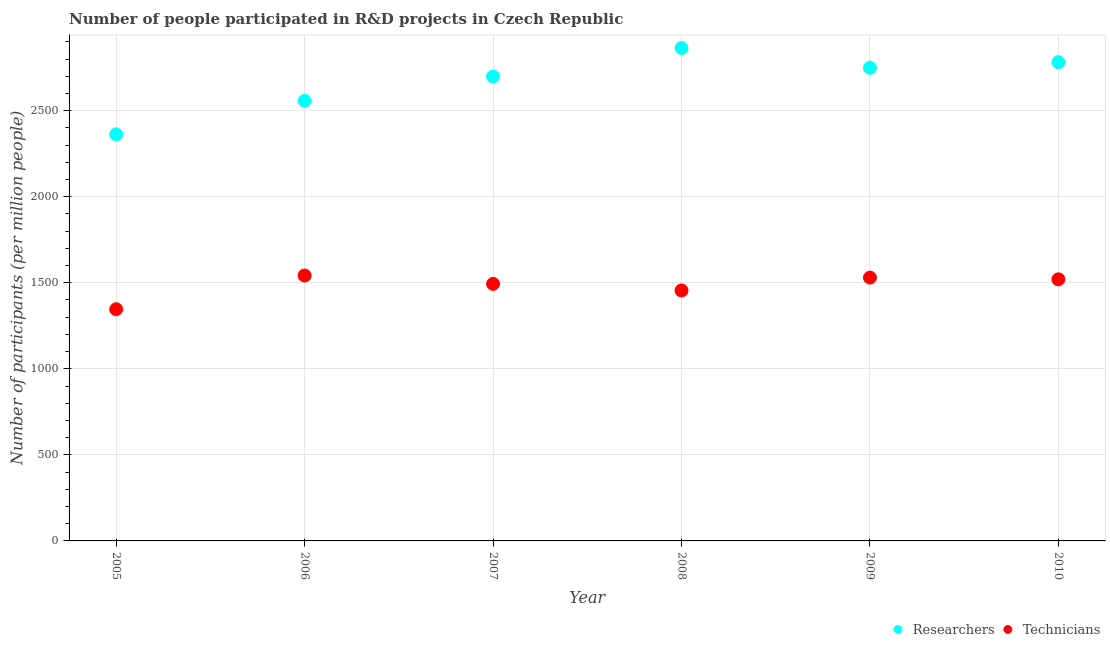Is the number of dotlines equal to the number of legend labels?
Offer a terse response. Yes. What is the number of researchers in 2010?
Keep it short and to the point. 2781.85. Across all years, what is the maximum number of technicians?
Your answer should be very brief. 1542.15. Across all years, what is the minimum number of researchers?
Make the answer very short. 2362.37. In which year was the number of technicians maximum?
Make the answer very short. 2006. What is the total number of researchers in the graph?
Give a very brief answer. 1.60e+04. What is the difference between the number of researchers in 2005 and that in 2008?
Your response must be concise. -502.15. What is the difference between the number of technicians in 2007 and the number of researchers in 2008?
Offer a very short reply. -1370.84. What is the average number of researchers per year?
Offer a very short reply. 2669.02. In the year 2010, what is the difference between the number of researchers and number of technicians?
Give a very brief answer. 1261.8. In how many years, is the number of technicians greater than 1200?
Provide a succinct answer. 6. What is the ratio of the number of researchers in 2005 to that in 2009?
Your response must be concise. 0.86. Is the number of researchers in 2006 less than that in 2009?
Provide a short and direct response. Yes. Is the difference between the number of technicians in 2008 and 2009 greater than the difference between the number of researchers in 2008 and 2009?
Ensure brevity in your answer.  No. What is the difference between the highest and the second highest number of technicians?
Ensure brevity in your answer.  12.06. What is the difference between the highest and the lowest number of technicians?
Your response must be concise. 195.97. Does the number of researchers monotonically increase over the years?
Your answer should be very brief. No. Is the number of researchers strictly greater than the number of technicians over the years?
Ensure brevity in your answer.  Yes. Is the number of technicians strictly less than the number of researchers over the years?
Give a very brief answer. Yes. How many dotlines are there?
Make the answer very short. 2. Does the graph contain any zero values?
Provide a succinct answer. No. Does the graph contain grids?
Keep it short and to the point. Yes. How many legend labels are there?
Your answer should be compact. 2. What is the title of the graph?
Provide a succinct answer. Number of people participated in R&D projects in Czech Republic. What is the label or title of the Y-axis?
Make the answer very short. Number of participants (per million people). What is the Number of participants (per million people) in Researchers in 2005?
Provide a short and direct response. 2362.37. What is the Number of participants (per million people) of Technicians in 2005?
Provide a short and direct response. 1346.19. What is the Number of participants (per million people) of Researchers in 2006?
Keep it short and to the point. 2557.31. What is the Number of participants (per million people) in Technicians in 2006?
Offer a terse response. 1542.15. What is the Number of participants (per million people) of Researchers in 2007?
Your answer should be compact. 2698.6. What is the Number of participants (per million people) of Technicians in 2007?
Provide a succinct answer. 1493.68. What is the Number of participants (per million people) of Researchers in 2008?
Offer a terse response. 2864.52. What is the Number of participants (per million people) in Technicians in 2008?
Keep it short and to the point. 1455.38. What is the Number of participants (per million people) of Researchers in 2009?
Your response must be concise. 2749.45. What is the Number of participants (per million people) of Technicians in 2009?
Your response must be concise. 1530.09. What is the Number of participants (per million people) of Researchers in 2010?
Provide a short and direct response. 2781.85. What is the Number of participants (per million people) in Technicians in 2010?
Ensure brevity in your answer.  1520.06. Across all years, what is the maximum Number of participants (per million people) in Researchers?
Make the answer very short. 2864.52. Across all years, what is the maximum Number of participants (per million people) of Technicians?
Your answer should be very brief. 1542.15. Across all years, what is the minimum Number of participants (per million people) of Researchers?
Provide a succinct answer. 2362.37. Across all years, what is the minimum Number of participants (per million people) of Technicians?
Provide a short and direct response. 1346.19. What is the total Number of participants (per million people) of Researchers in the graph?
Offer a terse response. 1.60e+04. What is the total Number of participants (per million people) in Technicians in the graph?
Offer a terse response. 8887.55. What is the difference between the Number of participants (per million people) of Researchers in 2005 and that in 2006?
Make the answer very short. -194.94. What is the difference between the Number of participants (per million people) in Technicians in 2005 and that in 2006?
Provide a short and direct response. -195.97. What is the difference between the Number of participants (per million people) of Researchers in 2005 and that in 2007?
Offer a terse response. -336.23. What is the difference between the Number of participants (per million people) of Technicians in 2005 and that in 2007?
Make the answer very short. -147.5. What is the difference between the Number of participants (per million people) in Researchers in 2005 and that in 2008?
Your answer should be very brief. -502.15. What is the difference between the Number of participants (per million people) in Technicians in 2005 and that in 2008?
Ensure brevity in your answer.  -109.19. What is the difference between the Number of participants (per million people) in Researchers in 2005 and that in 2009?
Give a very brief answer. -387.08. What is the difference between the Number of participants (per million people) in Technicians in 2005 and that in 2009?
Ensure brevity in your answer.  -183.91. What is the difference between the Number of participants (per million people) in Researchers in 2005 and that in 2010?
Provide a short and direct response. -419.49. What is the difference between the Number of participants (per million people) in Technicians in 2005 and that in 2010?
Ensure brevity in your answer.  -173.87. What is the difference between the Number of participants (per million people) in Researchers in 2006 and that in 2007?
Ensure brevity in your answer.  -141.29. What is the difference between the Number of participants (per million people) in Technicians in 2006 and that in 2007?
Your answer should be compact. 48.47. What is the difference between the Number of participants (per million people) of Researchers in 2006 and that in 2008?
Your response must be concise. -307.21. What is the difference between the Number of participants (per million people) in Technicians in 2006 and that in 2008?
Offer a very short reply. 86.78. What is the difference between the Number of participants (per million people) in Researchers in 2006 and that in 2009?
Provide a succinct answer. -192.14. What is the difference between the Number of participants (per million people) in Technicians in 2006 and that in 2009?
Your answer should be very brief. 12.06. What is the difference between the Number of participants (per million people) of Researchers in 2006 and that in 2010?
Provide a short and direct response. -224.55. What is the difference between the Number of participants (per million people) of Technicians in 2006 and that in 2010?
Make the answer very short. 22.1. What is the difference between the Number of participants (per million people) in Researchers in 2007 and that in 2008?
Offer a very short reply. -165.92. What is the difference between the Number of participants (per million people) of Technicians in 2007 and that in 2008?
Make the answer very short. 38.3. What is the difference between the Number of participants (per million people) in Researchers in 2007 and that in 2009?
Keep it short and to the point. -50.85. What is the difference between the Number of participants (per million people) of Technicians in 2007 and that in 2009?
Give a very brief answer. -36.41. What is the difference between the Number of participants (per million people) in Researchers in 2007 and that in 2010?
Provide a short and direct response. -83.26. What is the difference between the Number of participants (per million people) in Technicians in 2007 and that in 2010?
Offer a terse response. -26.38. What is the difference between the Number of participants (per million people) in Researchers in 2008 and that in 2009?
Give a very brief answer. 115.07. What is the difference between the Number of participants (per million people) of Technicians in 2008 and that in 2009?
Your response must be concise. -74.72. What is the difference between the Number of participants (per million people) in Researchers in 2008 and that in 2010?
Make the answer very short. 82.66. What is the difference between the Number of participants (per million people) of Technicians in 2008 and that in 2010?
Your response must be concise. -64.68. What is the difference between the Number of participants (per million people) in Researchers in 2009 and that in 2010?
Keep it short and to the point. -32.4. What is the difference between the Number of participants (per million people) in Technicians in 2009 and that in 2010?
Your response must be concise. 10.04. What is the difference between the Number of participants (per million people) in Researchers in 2005 and the Number of participants (per million people) in Technicians in 2006?
Your answer should be compact. 820.21. What is the difference between the Number of participants (per million people) in Researchers in 2005 and the Number of participants (per million people) in Technicians in 2007?
Provide a short and direct response. 868.68. What is the difference between the Number of participants (per million people) of Researchers in 2005 and the Number of participants (per million people) of Technicians in 2008?
Provide a succinct answer. 906.99. What is the difference between the Number of participants (per million people) of Researchers in 2005 and the Number of participants (per million people) of Technicians in 2009?
Keep it short and to the point. 832.27. What is the difference between the Number of participants (per million people) in Researchers in 2005 and the Number of participants (per million people) in Technicians in 2010?
Offer a very short reply. 842.31. What is the difference between the Number of participants (per million people) of Researchers in 2006 and the Number of participants (per million people) of Technicians in 2007?
Offer a very short reply. 1063.62. What is the difference between the Number of participants (per million people) of Researchers in 2006 and the Number of participants (per million people) of Technicians in 2008?
Ensure brevity in your answer.  1101.93. What is the difference between the Number of participants (per million people) in Researchers in 2006 and the Number of participants (per million people) in Technicians in 2009?
Keep it short and to the point. 1027.21. What is the difference between the Number of participants (per million people) of Researchers in 2006 and the Number of participants (per million people) of Technicians in 2010?
Ensure brevity in your answer.  1037.25. What is the difference between the Number of participants (per million people) of Researchers in 2007 and the Number of participants (per million people) of Technicians in 2008?
Make the answer very short. 1243.22. What is the difference between the Number of participants (per million people) of Researchers in 2007 and the Number of participants (per million people) of Technicians in 2009?
Make the answer very short. 1168.5. What is the difference between the Number of participants (per million people) of Researchers in 2007 and the Number of participants (per million people) of Technicians in 2010?
Offer a terse response. 1178.54. What is the difference between the Number of participants (per million people) of Researchers in 2008 and the Number of participants (per million people) of Technicians in 2009?
Offer a very short reply. 1334.42. What is the difference between the Number of participants (per million people) in Researchers in 2008 and the Number of participants (per million people) in Technicians in 2010?
Offer a terse response. 1344.46. What is the difference between the Number of participants (per million people) of Researchers in 2009 and the Number of participants (per million people) of Technicians in 2010?
Make the answer very short. 1229.39. What is the average Number of participants (per million people) in Researchers per year?
Make the answer very short. 2669.02. What is the average Number of participants (per million people) in Technicians per year?
Your response must be concise. 1481.26. In the year 2005, what is the difference between the Number of participants (per million people) in Researchers and Number of participants (per million people) in Technicians?
Your response must be concise. 1016.18. In the year 2006, what is the difference between the Number of participants (per million people) in Researchers and Number of participants (per million people) in Technicians?
Your answer should be compact. 1015.15. In the year 2007, what is the difference between the Number of participants (per million people) of Researchers and Number of participants (per million people) of Technicians?
Keep it short and to the point. 1204.92. In the year 2008, what is the difference between the Number of participants (per million people) in Researchers and Number of participants (per million people) in Technicians?
Offer a terse response. 1409.14. In the year 2009, what is the difference between the Number of participants (per million people) of Researchers and Number of participants (per million people) of Technicians?
Keep it short and to the point. 1219.36. In the year 2010, what is the difference between the Number of participants (per million people) in Researchers and Number of participants (per million people) in Technicians?
Provide a succinct answer. 1261.8. What is the ratio of the Number of participants (per million people) of Researchers in 2005 to that in 2006?
Offer a very short reply. 0.92. What is the ratio of the Number of participants (per million people) of Technicians in 2005 to that in 2006?
Ensure brevity in your answer.  0.87. What is the ratio of the Number of participants (per million people) in Researchers in 2005 to that in 2007?
Your answer should be very brief. 0.88. What is the ratio of the Number of participants (per million people) in Technicians in 2005 to that in 2007?
Offer a terse response. 0.9. What is the ratio of the Number of participants (per million people) of Researchers in 2005 to that in 2008?
Your response must be concise. 0.82. What is the ratio of the Number of participants (per million people) in Technicians in 2005 to that in 2008?
Your answer should be compact. 0.93. What is the ratio of the Number of participants (per million people) in Researchers in 2005 to that in 2009?
Keep it short and to the point. 0.86. What is the ratio of the Number of participants (per million people) of Technicians in 2005 to that in 2009?
Make the answer very short. 0.88. What is the ratio of the Number of participants (per million people) of Researchers in 2005 to that in 2010?
Make the answer very short. 0.85. What is the ratio of the Number of participants (per million people) in Technicians in 2005 to that in 2010?
Your answer should be compact. 0.89. What is the ratio of the Number of participants (per million people) in Researchers in 2006 to that in 2007?
Your response must be concise. 0.95. What is the ratio of the Number of participants (per million people) in Technicians in 2006 to that in 2007?
Provide a succinct answer. 1.03. What is the ratio of the Number of participants (per million people) of Researchers in 2006 to that in 2008?
Ensure brevity in your answer.  0.89. What is the ratio of the Number of participants (per million people) in Technicians in 2006 to that in 2008?
Give a very brief answer. 1.06. What is the ratio of the Number of participants (per million people) in Researchers in 2006 to that in 2009?
Provide a short and direct response. 0.93. What is the ratio of the Number of participants (per million people) in Technicians in 2006 to that in 2009?
Give a very brief answer. 1.01. What is the ratio of the Number of participants (per million people) of Researchers in 2006 to that in 2010?
Your answer should be compact. 0.92. What is the ratio of the Number of participants (per million people) in Technicians in 2006 to that in 2010?
Offer a terse response. 1.01. What is the ratio of the Number of participants (per million people) of Researchers in 2007 to that in 2008?
Make the answer very short. 0.94. What is the ratio of the Number of participants (per million people) in Technicians in 2007 to that in 2008?
Your response must be concise. 1.03. What is the ratio of the Number of participants (per million people) in Researchers in 2007 to that in 2009?
Provide a succinct answer. 0.98. What is the ratio of the Number of participants (per million people) in Technicians in 2007 to that in 2009?
Provide a succinct answer. 0.98. What is the ratio of the Number of participants (per million people) of Researchers in 2007 to that in 2010?
Give a very brief answer. 0.97. What is the ratio of the Number of participants (per million people) in Technicians in 2007 to that in 2010?
Provide a succinct answer. 0.98. What is the ratio of the Number of participants (per million people) in Researchers in 2008 to that in 2009?
Provide a short and direct response. 1.04. What is the ratio of the Number of participants (per million people) in Technicians in 2008 to that in 2009?
Provide a succinct answer. 0.95. What is the ratio of the Number of participants (per million people) of Researchers in 2008 to that in 2010?
Ensure brevity in your answer.  1.03. What is the ratio of the Number of participants (per million people) of Technicians in 2008 to that in 2010?
Your answer should be compact. 0.96. What is the ratio of the Number of participants (per million people) of Researchers in 2009 to that in 2010?
Provide a short and direct response. 0.99. What is the ratio of the Number of participants (per million people) of Technicians in 2009 to that in 2010?
Provide a short and direct response. 1.01. What is the difference between the highest and the second highest Number of participants (per million people) of Researchers?
Make the answer very short. 82.66. What is the difference between the highest and the second highest Number of participants (per million people) of Technicians?
Make the answer very short. 12.06. What is the difference between the highest and the lowest Number of participants (per million people) of Researchers?
Your answer should be very brief. 502.15. What is the difference between the highest and the lowest Number of participants (per million people) in Technicians?
Offer a terse response. 195.97. 